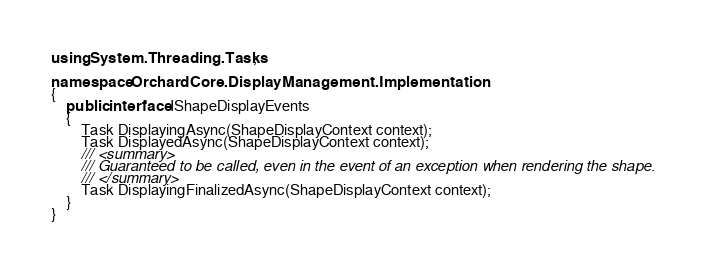Convert code to text. <code><loc_0><loc_0><loc_500><loc_500><_C#_>using System.Threading.Tasks;

namespace OrchardCore.DisplayManagement.Implementation
{
    public interface IShapeDisplayEvents
    {
        Task DisplayingAsync(ShapeDisplayContext context);
        Task DisplayedAsync(ShapeDisplayContext context);
        /// <summary>
        /// Guaranteed to be called, even in the event of an exception when rendering the shape.
        /// </summary>
        Task DisplayingFinalizedAsync(ShapeDisplayContext context);
    }
}
</code> 